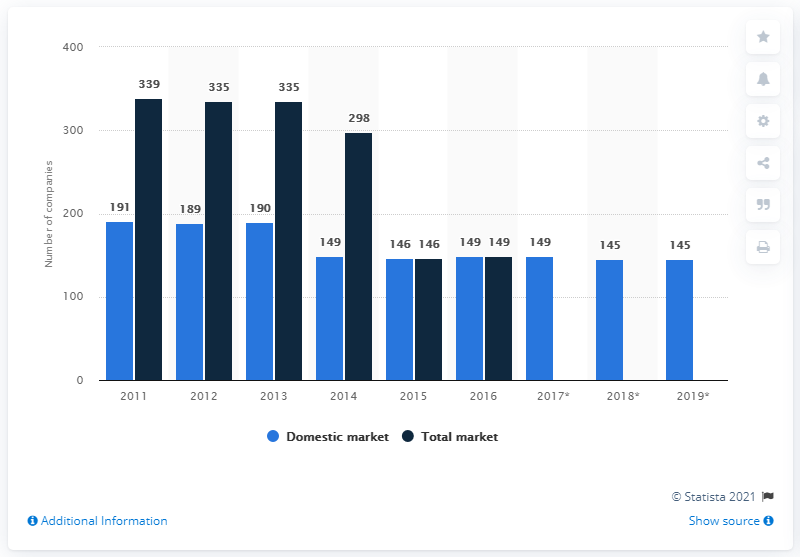Outline some significant characteristics in this image. The same number of companies has existed in the domestic market for 2 years. There were 145 insurance companies in business in Switzerland at the end of 2019. The average of the total market is 267. 